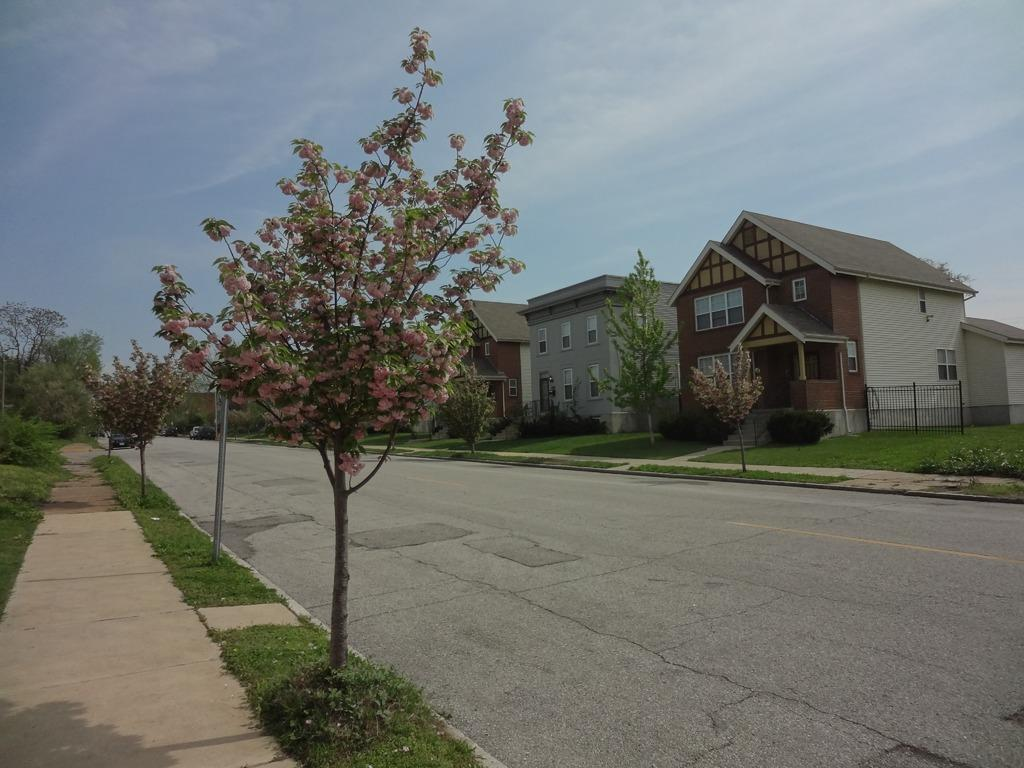What is the color of the house in the image? The house in the image is brown. What type of roof does the house have? The house has roof tiles. What can be seen in the center of the image? There is a road in the front center of the image. What type of vegetation is on the left side of the image? There is a small tree on the left side of the image. How long does it take for the news to reach the house in the image? There is no indication of news or time in the image, so it cannot be determined. 